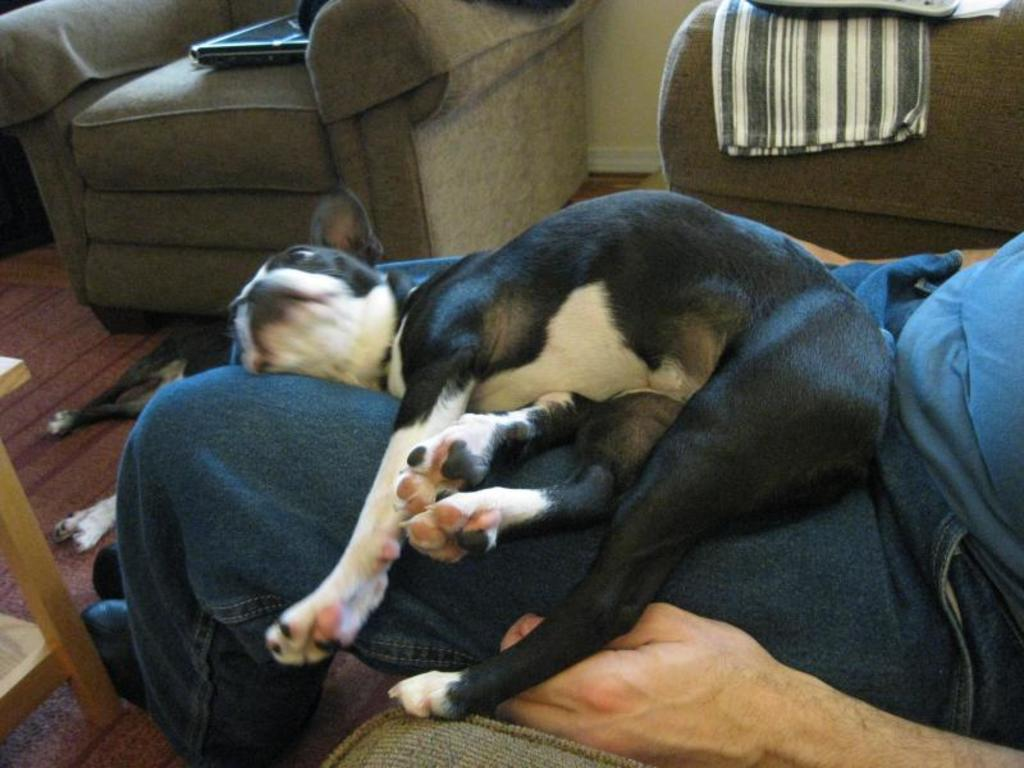What is the person in the image doing? The person is sitting on a couch in the image. What is lying on the person? A dog is lying on the person. What type of furniture is visible in the image? There is a sofa in the image. What electronic device can be seen in the image? A laptop is present in the image. What else is visible in the image besides the person and the dog? There are clothes visible in the image. Where is the second dog in the image? There is a dog lying on the floor in the image. What type of army vehicle can be seen in the image? There is no army vehicle present in the image. What kind of beetle is crawling on the laptop in the image? There is no beetle visible in the image, and the laptop is not mentioned to have any insects on it. 